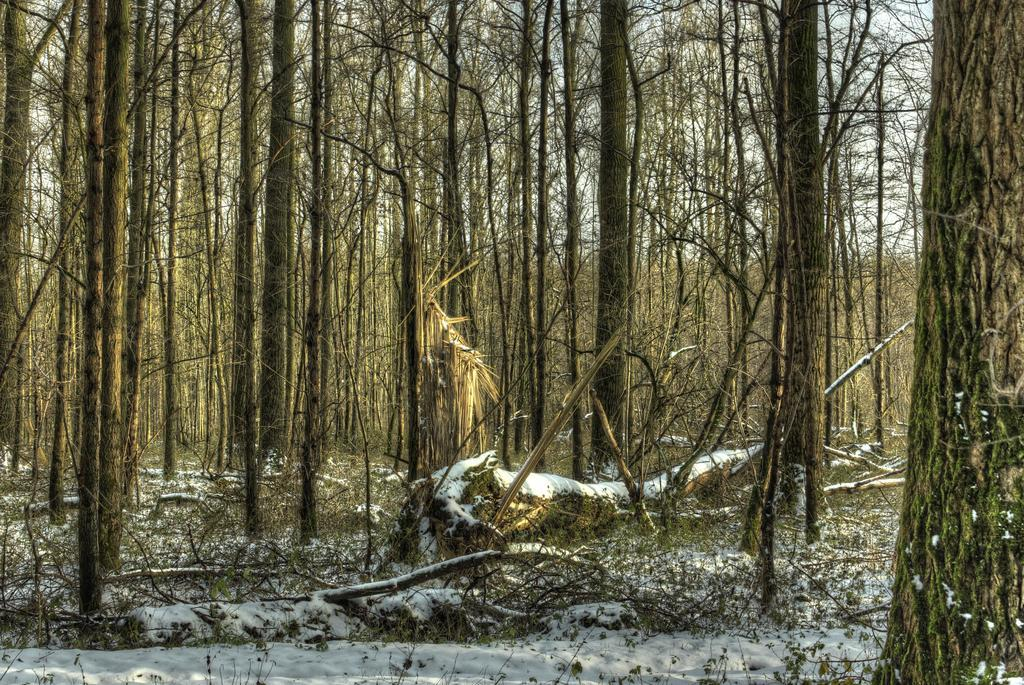What type of natural objects can be seen in the image? There are trunks of trees in the image. What is covering the ground in the image? The ground is covered with snow. What arithmetic problem is being solved by the animal in the image? There is no animal or arithmetic problem present in the image. 